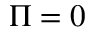<formula> <loc_0><loc_0><loc_500><loc_500>\Pi = 0</formula> 